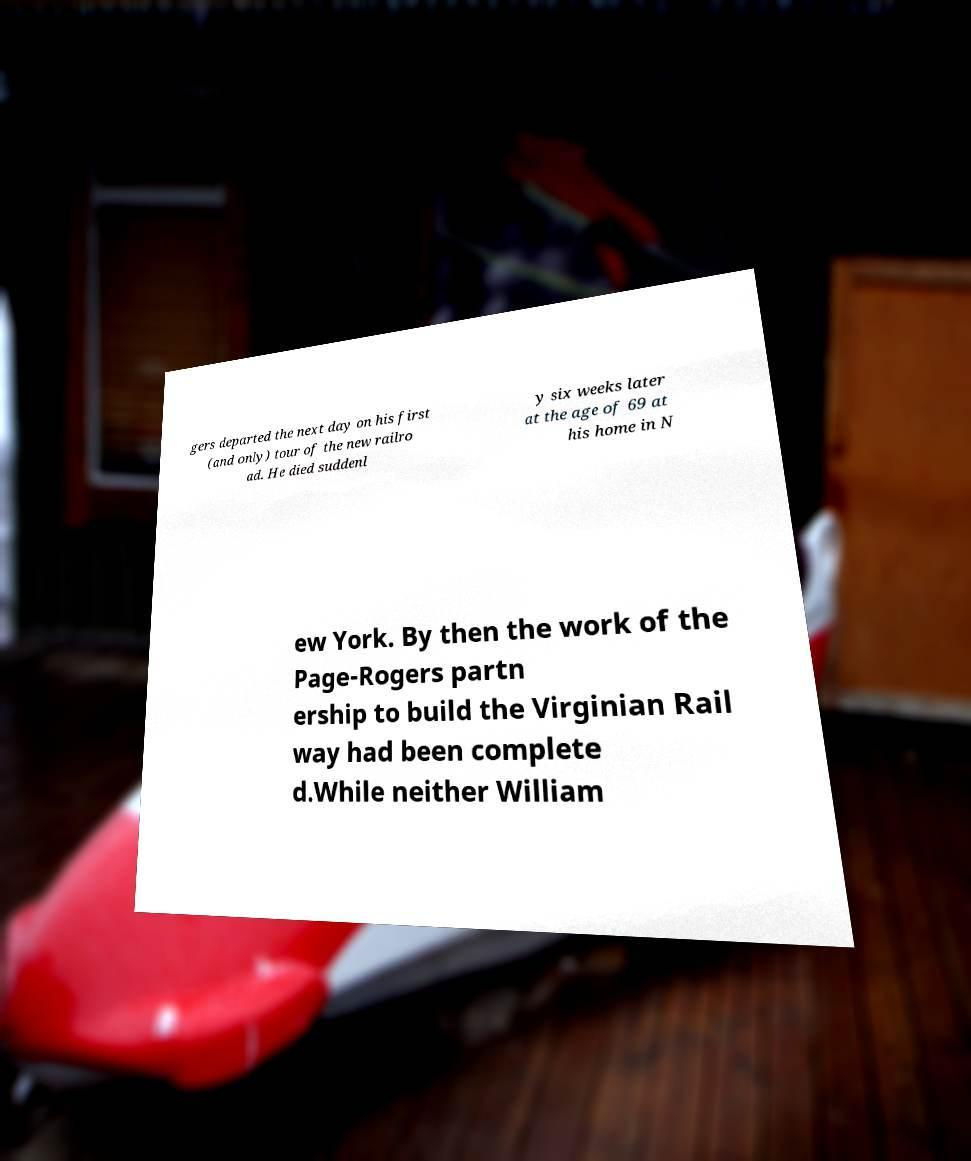Please identify and transcribe the text found in this image. gers departed the next day on his first (and only) tour of the new railro ad. He died suddenl y six weeks later at the age of 69 at his home in N ew York. By then the work of the Page-Rogers partn ership to build the Virginian Rail way had been complete d.While neither William 